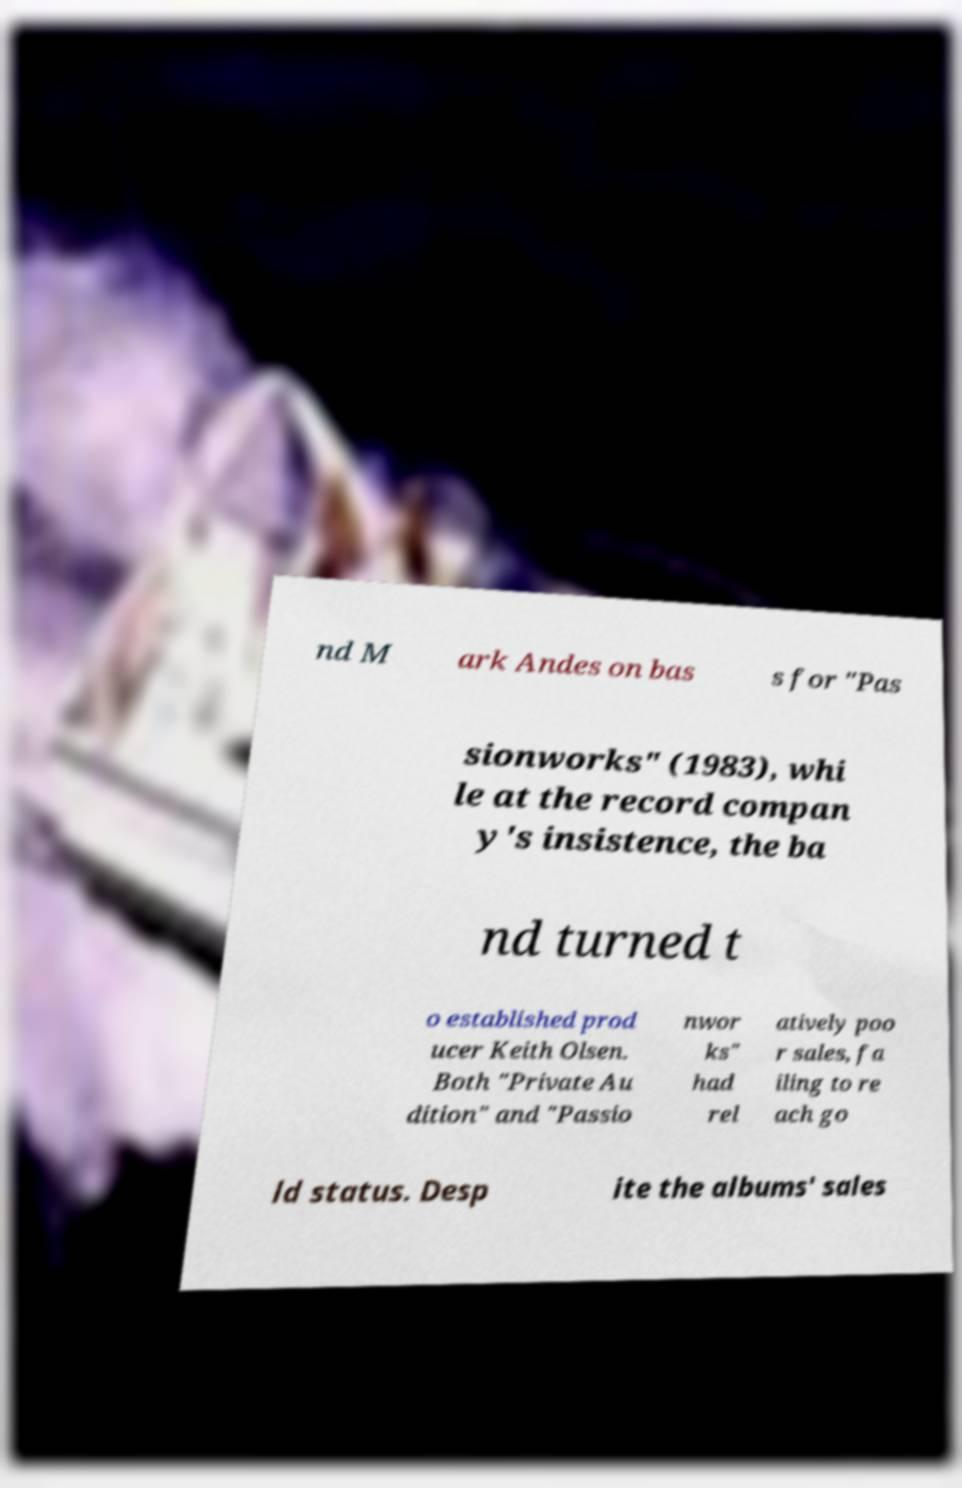For documentation purposes, I need the text within this image transcribed. Could you provide that? nd M ark Andes on bas s for "Pas sionworks" (1983), whi le at the record compan y's insistence, the ba nd turned t o established prod ucer Keith Olsen. Both "Private Au dition" and "Passio nwor ks" had rel atively poo r sales, fa iling to re ach go ld status. Desp ite the albums' sales 